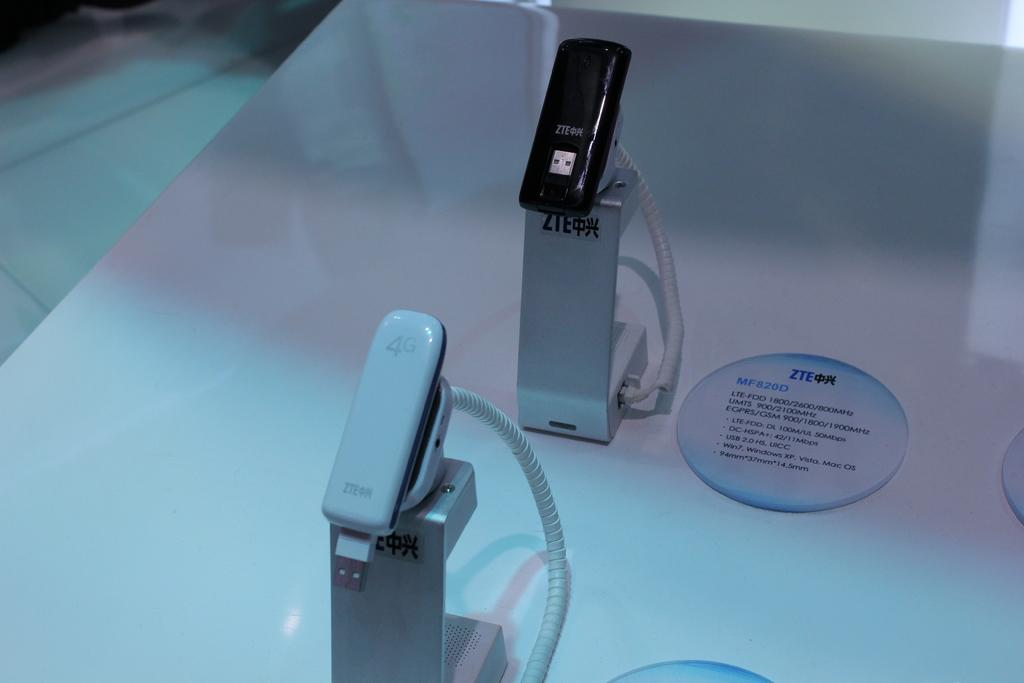<image>
Render a clear and concise summary of the photo. Several different usb devices, one of which is a 4G, the other ZTE. 